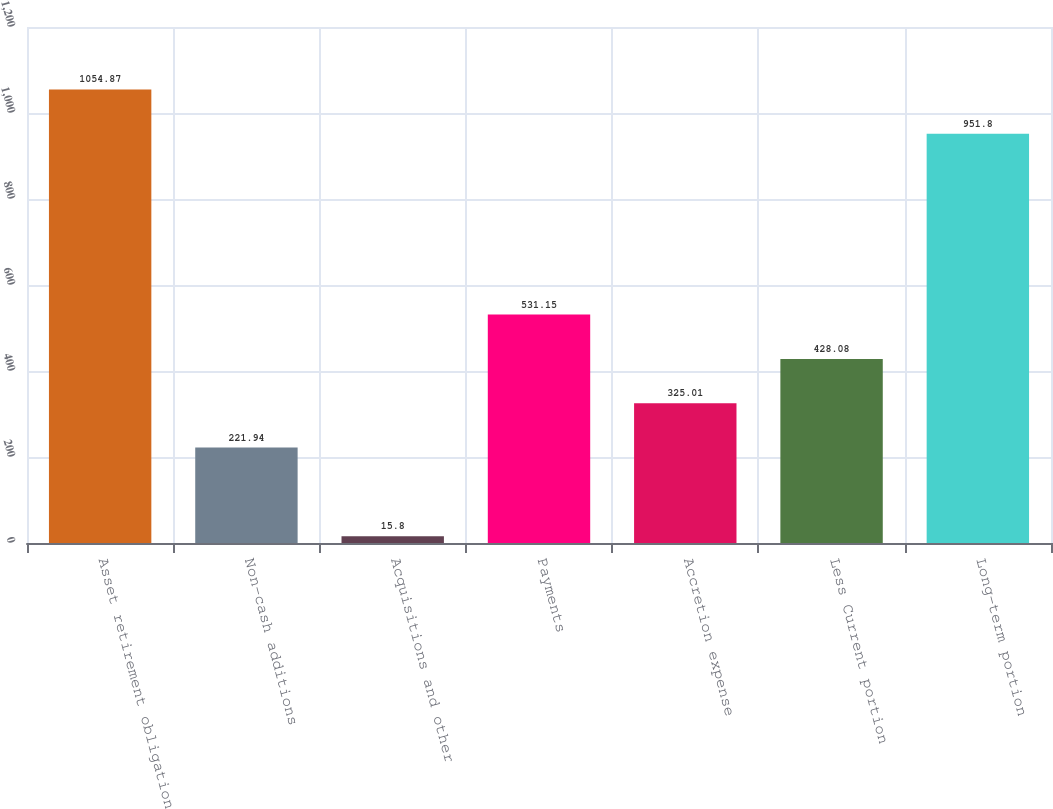<chart> <loc_0><loc_0><loc_500><loc_500><bar_chart><fcel>Asset retirement obligation<fcel>Non-cash additions<fcel>Acquisitions and other<fcel>Payments<fcel>Accretion expense<fcel>Less Current portion<fcel>Long-term portion<nl><fcel>1054.87<fcel>221.94<fcel>15.8<fcel>531.15<fcel>325.01<fcel>428.08<fcel>951.8<nl></chart> 